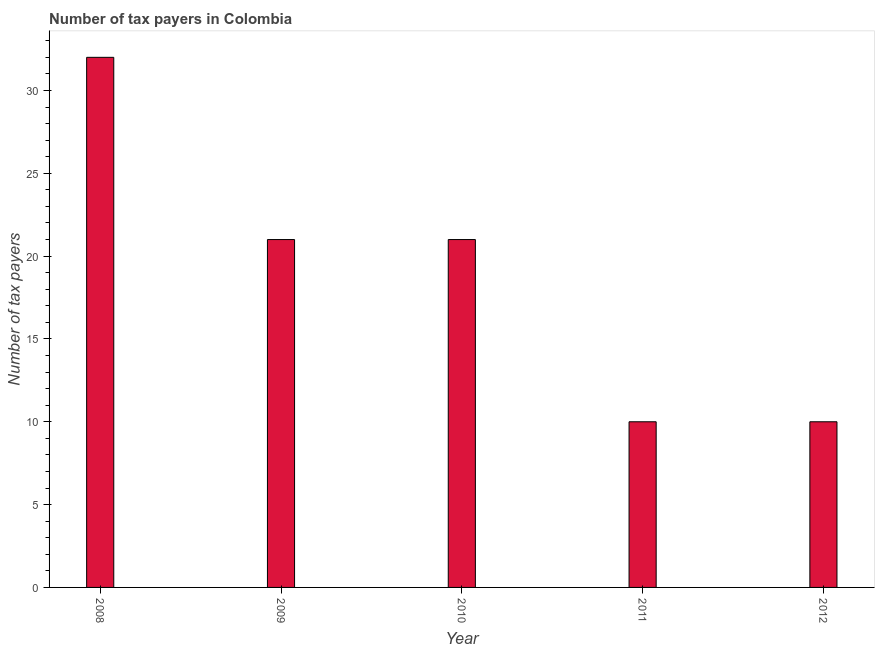Does the graph contain grids?
Provide a succinct answer. No. What is the title of the graph?
Provide a succinct answer. Number of tax payers in Colombia. What is the label or title of the Y-axis?
Ensure brevity in your answer.  Number of tax payers. What is the number of tax payers in 2009?
Ensure brevity in your answer.  21. What is the sum of the number of tax payers?
Provide a short and direct response. 94. What is the difference between the number of tax payers in 2008 and 2012?
Your answer should be compact. 22. In how many years, is the number of tax payers greater than 26 ?
Keep it short and to the point. 1. What is the ratio of the number of tax payers in 2009 to that in 2012?
Your response must be concise. 2.1. Is the number of tax payers in 2011 less than that in 2012?
Offer a terse response. No. What is the difference between the highest and the second highest number of tax payers?
Your answer should be very brief. 11. Is the sum of the number of tax payers in 2008 and 2010 greater than the maximum number of tax payers across all years?
Keep it short and to the point. Yes. What is the difference between the highest and the lowest number of tax payers?
Give a very brief answer. 22. How many years are there in the graph?
Your answer should be compact. 5. What is the Number of tax payers in 2009?
Your answer should be compact. 21. What is the Number of tax payers of 2011?
Provide a succinct answer. 10. What is the difference between the Number of tax payers in 2008 and 2009?
Provide a short and direct response. 11. What is the difference between the Number of tax payers in 2008 and 2011?
Keep it short and to the point. 22. What is the difference between the Number of tax payers in 2008 and 2012?
Your answer should be very brief. 22. What is the difference between the Number of tax payers in 2009 and 2010?
Keep it short and to the point. 0. What is the difference between the Number of tax payers in 2009 and 2011?
Keep it short and to the point. 11. What is the difference between the Number of tax payers in 2010 and 2011?
Provide a short and direct response. 11. What is the difference between the Number of tax payers in 2010 and 2012?
Offer a very short reply. 11. What is the difference between the Number of tax payers in 2011 and 2012?
Your response must be concise. 0. What is the ratio of the Number of tax payers in 2008 to that in 2009?
Make the answer very short. 1.52. What is the ratio of the Number of tax payers in 2008 to that in 2010?
Make the answer very short. 1.52. What is the ratio of the Number of tax payers in 2008 to that in 2011?
Keep it short and to the point. 3.2. What is the ratio of the Number of tax payers in 2008 to that in 2012?
Ensure brevity in your answer.  3.2. What is the ratio of the Number of tax payers in 2009 to that in 2010?
Offer a terse response. 1. What is the ratio of the Number of tax payers in 2009 to that in 2011?
Your response must be concise. 2.1. What is the ratio of the Number of tax payers in 2009 to that in 2012?
Provide a succinct answer. 2.1. 